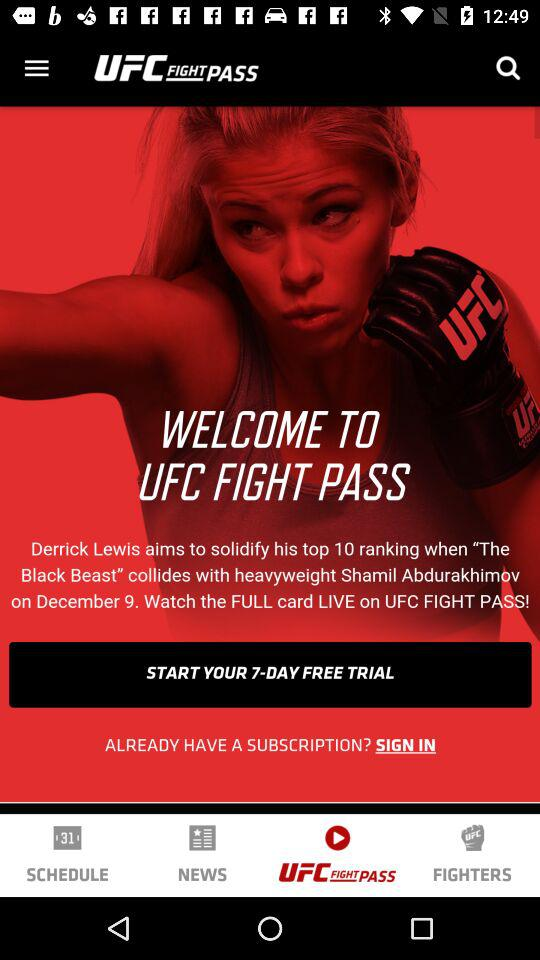Which tab is selected? The selected tab is "UFC FIGHT PASS". 